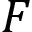<formula> <loc_0><loc_0><loc_500><loc_500>F</formula> 